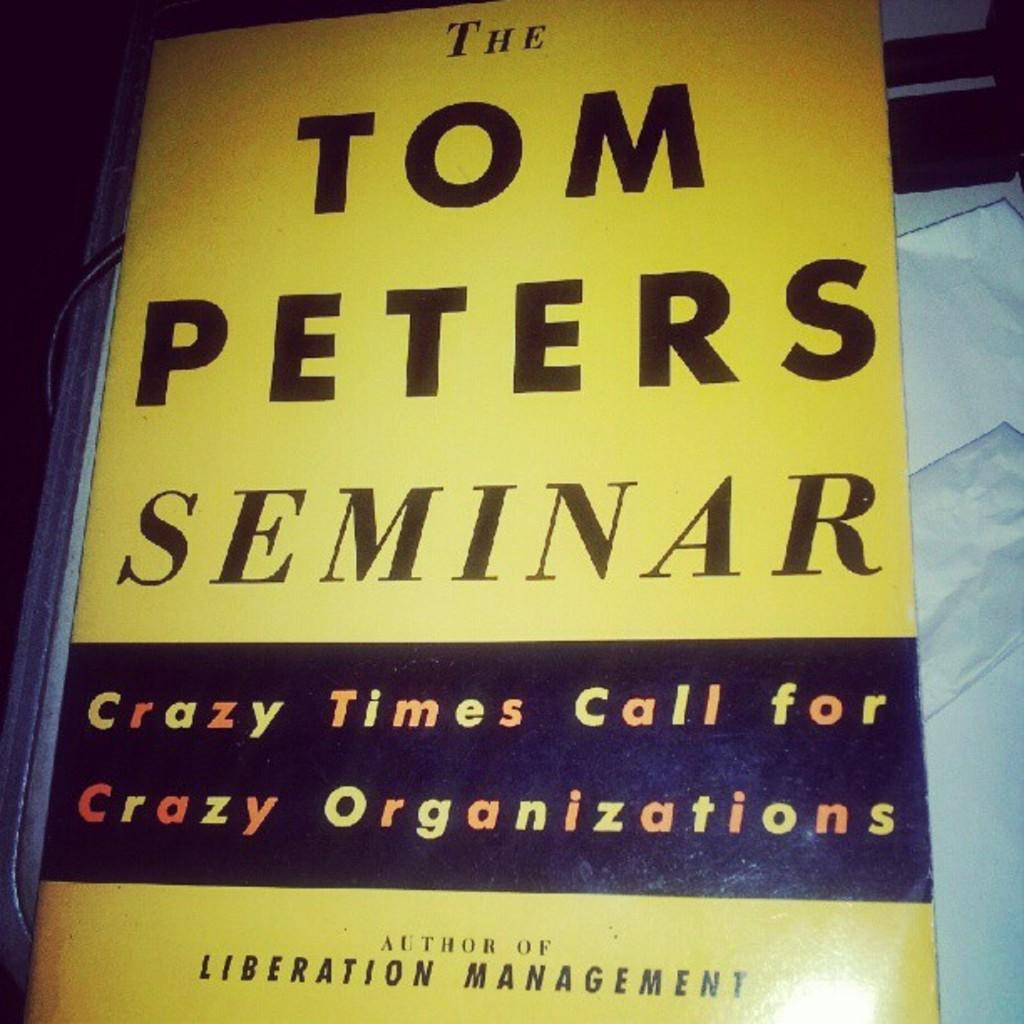<image>
Offer a succinct explanation of the picture presented. A yellow book cover titled the Tom Peters Seminar. 